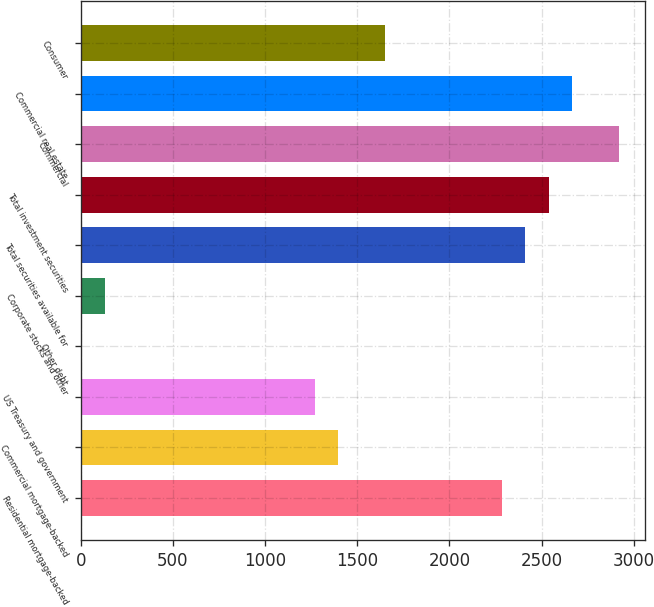Convert chart. <chart><loc_0><loc_0><loc_500><loc_500><bar_chart><fcel>Residential mortgage-backed<fcel>Commercial mortgage-backed<fcel>US Treasury and government<fcel>Other debt<fcel>Corporate stocks and other<fcel>Total securities available for<fcel>Total investment securities<fcel>Commercial<fcel>Commercial real estate<fcel>Consumer<nl><fcel>2284.6<fcel>1397.7<fcel>1271<fcel>4<fcel>130.7<fcel>2411.3<fcel>2538<fcel>2918.1<fcel>2664.7<fcel>1651.1<nl></chart> 